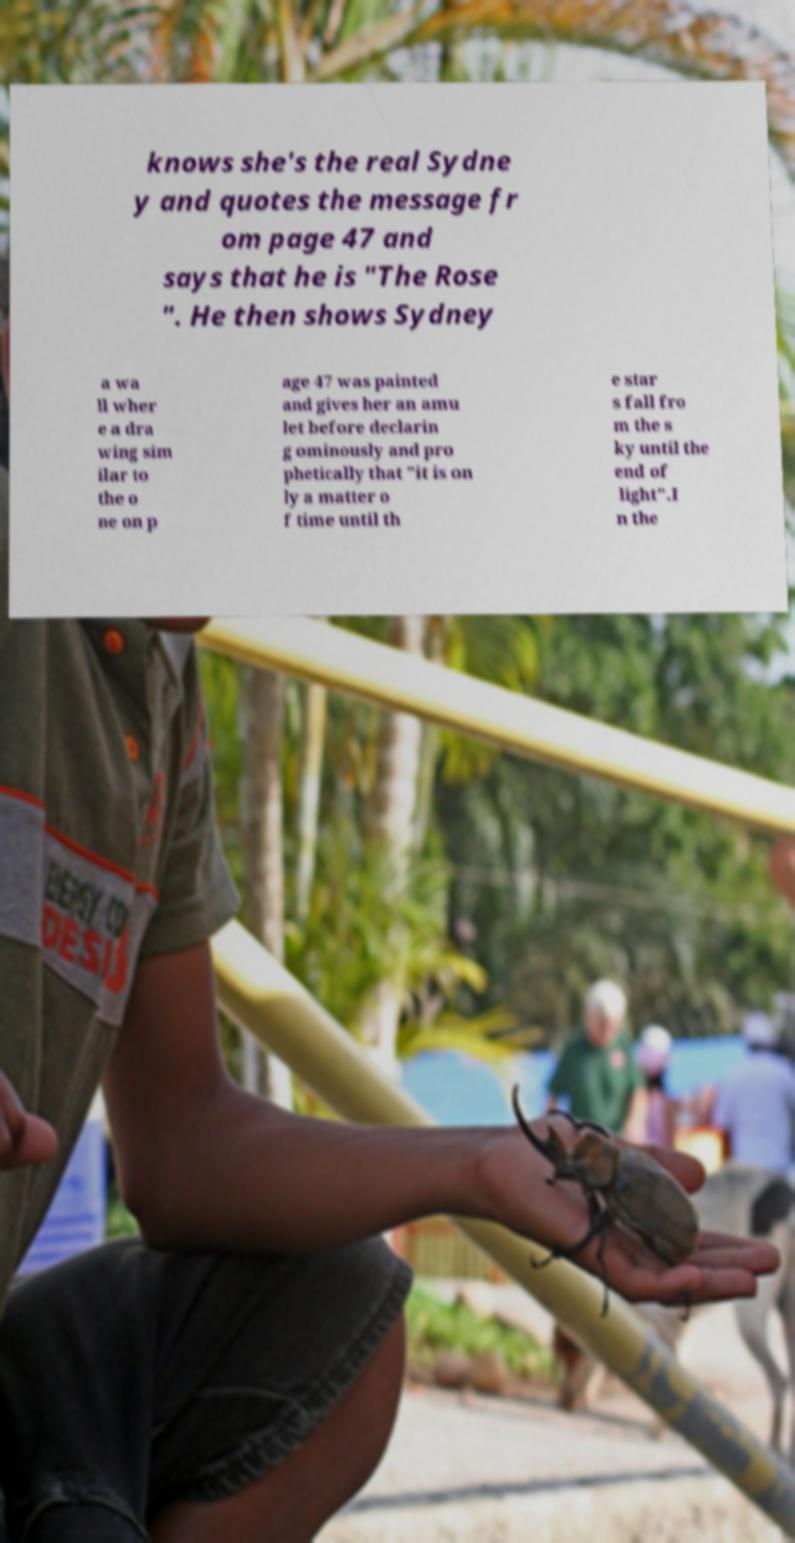Can you accurately transcribe the text from the provided image for me? knows she's the real Sydne y and quotes the message fr om page 47 and says that he is "The Rose ". He then shows Sydney a wa ll wher e a dra wing sim ilar to the o ne on p age 47 was painted and gives her an amu let before declarin g ominously and pro phetically that "it is on ly a matter o f time until th e star s fall fro m the s ky until the end of light".I n the 